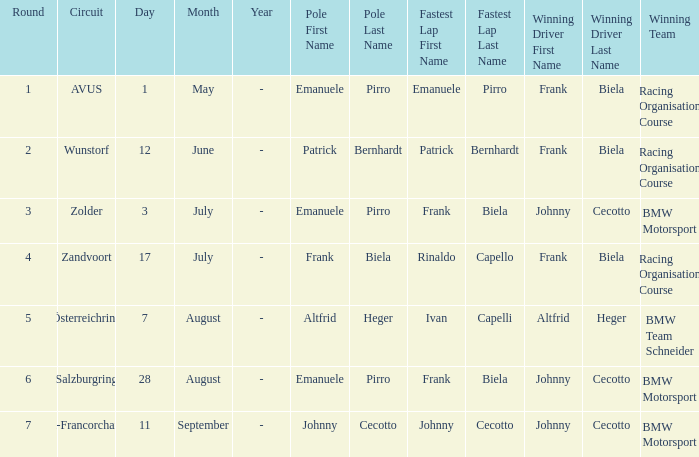Who was the winning team on the circuit Zolder? BMW Motorsport. Can you parse all the data within this table? {'header': ['Round', 'Circuit', 'Day', 'Month', 'Year', 'Pole First Name', 'Pole Last Name', 'Fastest Lap First Name', 'Fastest Lap Last Name', 'Winning Driver First Name', 'Winning Driver Last Name', 'Winning Team'], 'rows': [['1', 'AVUS', '1', 'May', '-', 'Emanuele', 'Pirro', 'Emanuele', 'Pirro', 'Frank', 'Biela', 'Racing Organisation Course'], ['2', 'Wunstorf', '12', 'June', '-', 'Patrick', 'Bernhardt', 'Patrick', 'Bernhardt', 'Frank', 'Biela', 'Racing Organisation Course'], ['3', 'Zolder', '3', 'July', '-', 'Emanuele', 'Pirro', 'Frank', 'Biela', 'Johnny', 'Cecotto', 'BMW Motorsport'], ['4', 'Zandvoort', '17', 'July', '-', 'Frank', 'Biela', 'Rinaldo', 'Capello', 'Frank', 'Biela', 'Racing Organisation Course'], ['5', 'Österreichring', '7', 'August', '-', 'Altfrid', 'Heger', 'Ivan', 'Capelli', 'Altfrid', 'Heger', 'BMW Team Schneider'], ['6', 'Salzburgring', '28', 'August', '-', 'Emanuele', 'Pirro', 'Frank', 'Biela', 'Johnny', 'Cecotto', 'BMW Motorsport'], ['7', 'Spa-Francorchamps', '11', 'September', '-', 'Johnny', 'Cecotto', 'Johnny', 'Cecotto', 'Johnny', 'Cecotto', 'BMW Motorsport']]} 